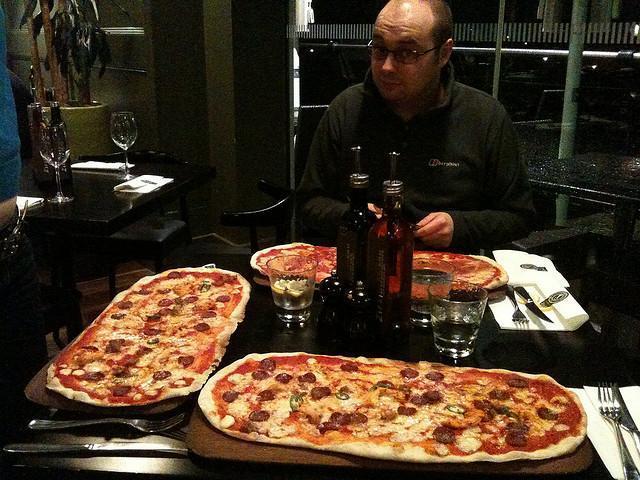How many pizzas are there?
Give a very brief answer. 3. How many cups are there?
Give a very brief answer. 2. How many dining tables are in the photo?
Give a very brief answer. 3. How many people are there?
Give a very brief answer. 2. How many bottles are there?
Give a very brief answer. 2. 